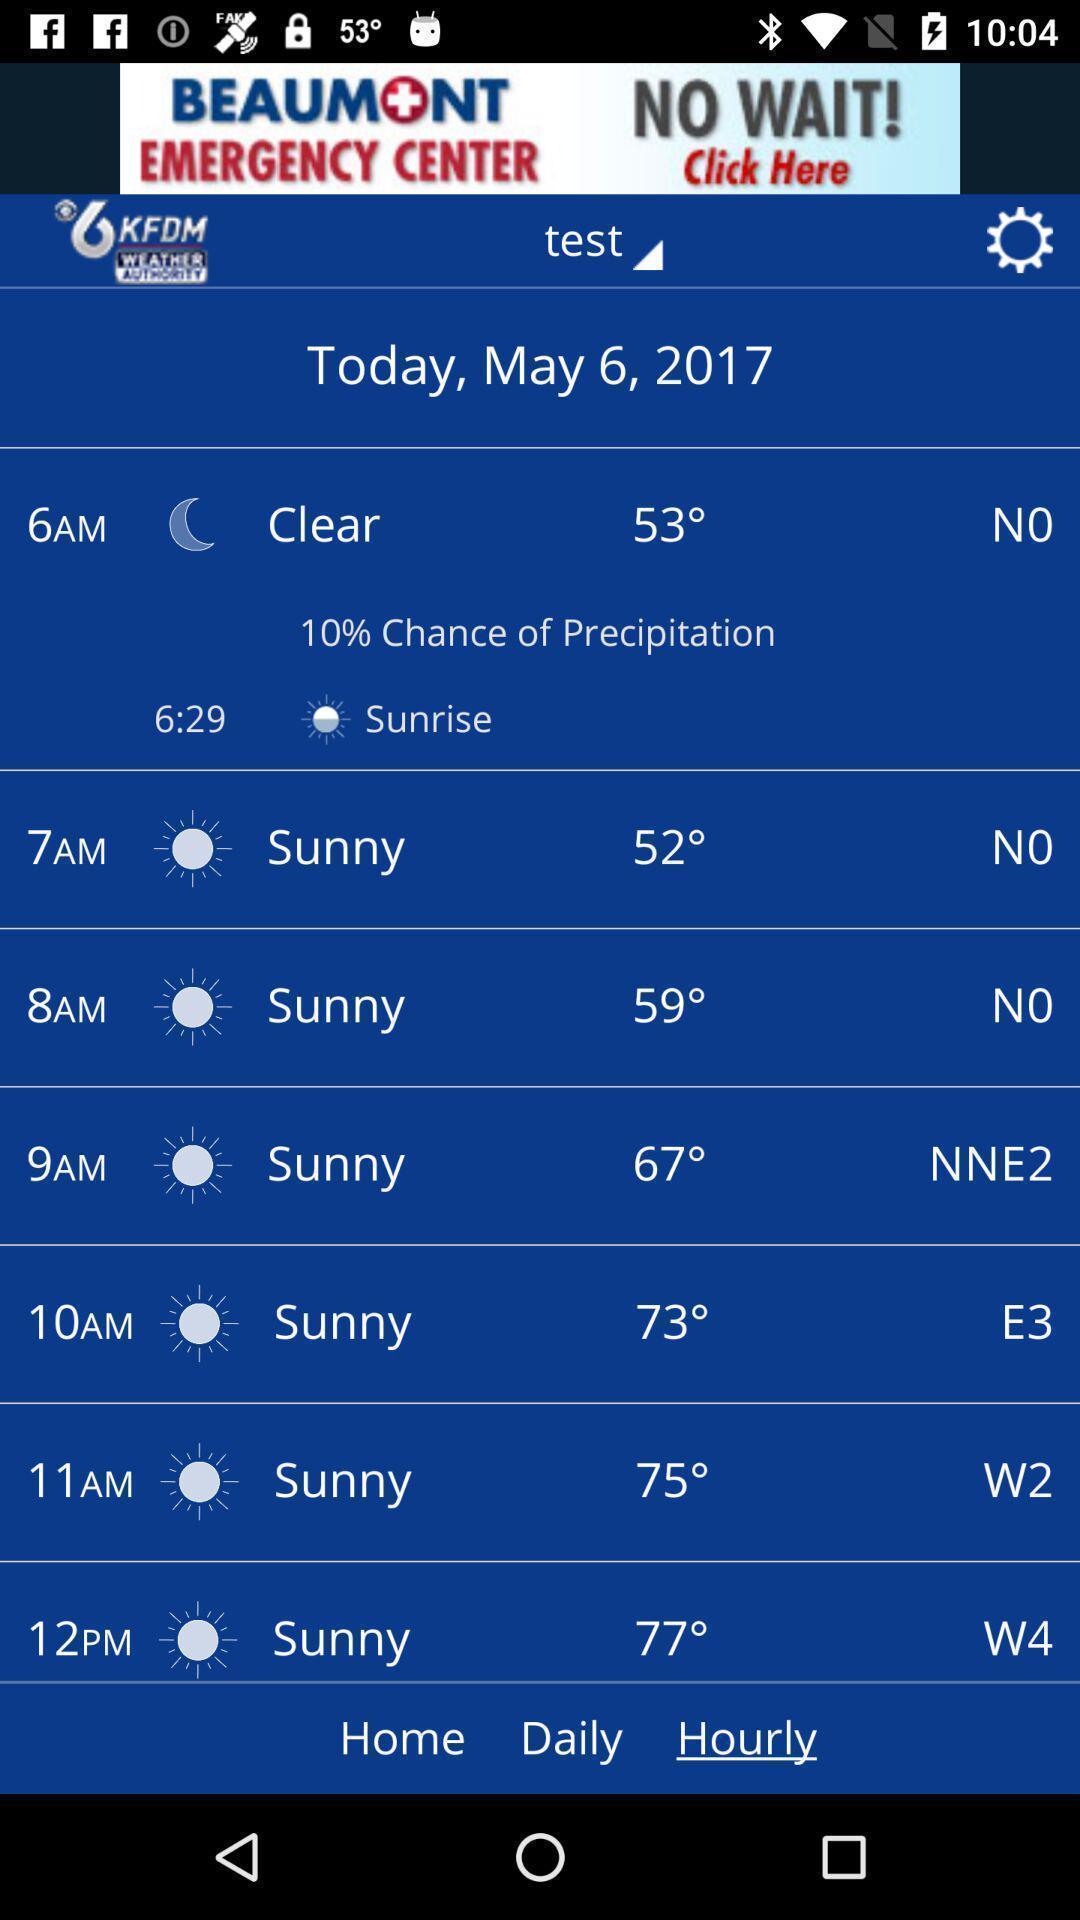Explain the elements present in this screenshot. Page displaying the weather notification options. 